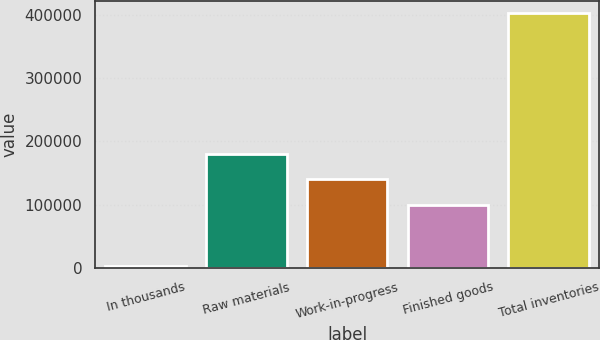<chart> <loc_0><loc_0><loc_500><loc_500><bar_chart><fcel>In thousands<fcel>Raw materials<fcel>Work-in-progress<fcel>Finished goods<fcel>Total inventories<nl><fcel>2013<fcel>180117<fcel>139996<fcel>99874<fcel>403229<nl></chart> 